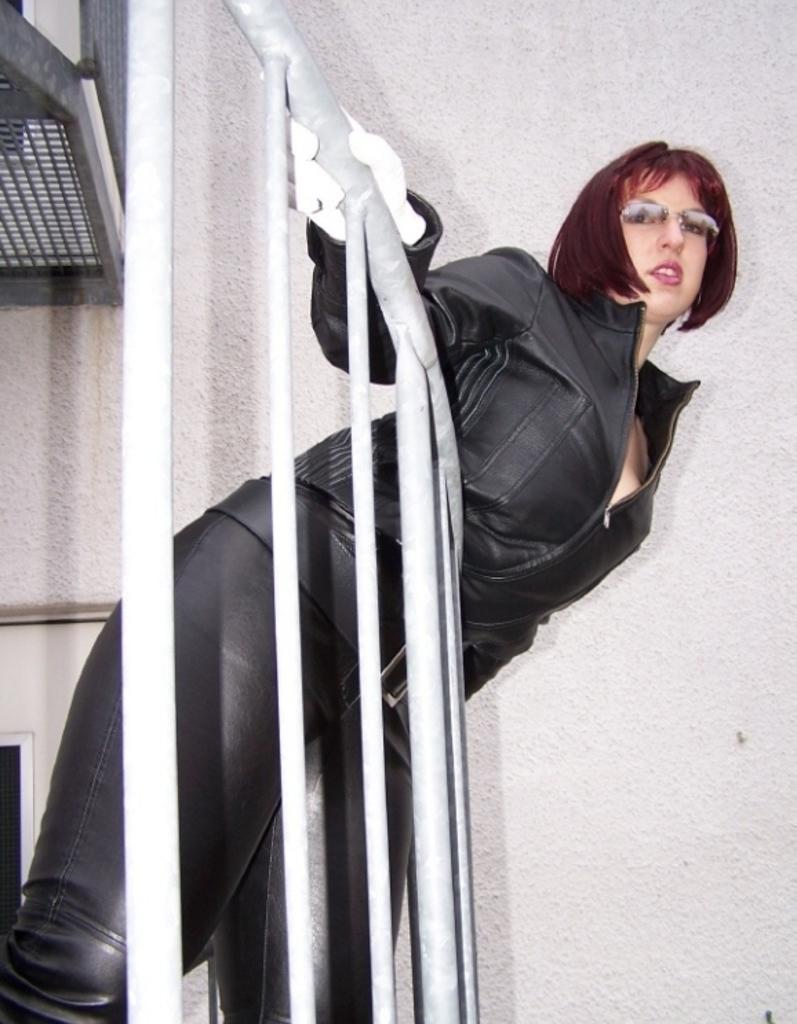Who is present in the image? There is a woman in the image. What is the woman wearing? The woman is wearing a black dress, gloves, and glasses. Where is the woman located in the image? The woman is standing near the railing. What can be seen in the background of the image? There is a wall in the background of the image. Are there any other people visible in the image? Yes, there are girls visible on the left side of the image. What type of crate is visible on the right side of the image? There is no crate present in the image. What is the woman using to play the pipe in the image? The woman is not playing a pipe in the image; she is wearing gloves and standing near the railing. 